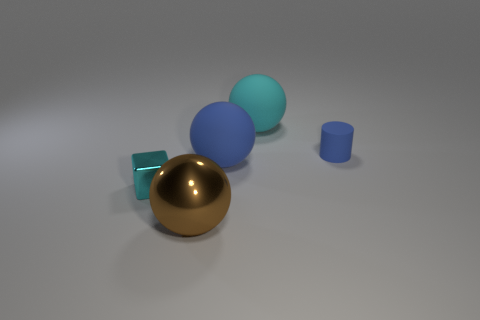What number of green objects are either rubber objects or big metal spheres?
Offer a very short reply. 0. Is there a small cube that has the same color as the rubber cylinder?
Offer a terse response. No. Are there any large green balls made of the same material as the cylinder?
Your response must be concise. No. There is a object that is both to the right of the small metallic thing and in front of the big blue rubber thing; what shape is it?
Your response must be concise. Sphere. What number of big things are shiny things or balls?
Ensure brevity in your answer.  3. What is the tiny blue thing made of?
Make the answer very short. Rubber. How many other things are there of the same shape as the large cyan rubber object?
Keep it short and to the point. 2. What size is the cube?
Provide a short and direct response. Small. What size is the object that is both in front of the large blue matte ball and right of the tiny metallic object?
Provide a succinct answer. Large. What is the shape of the big rubber object in front of the cyan rubber thing?
Keep it short and to the point. Sphere. 